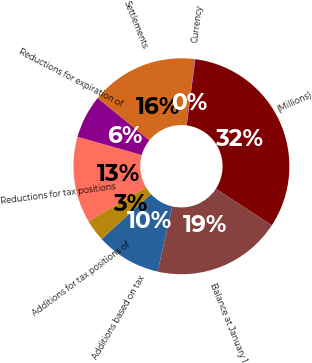Convert chart to OTSL. <chart><loc_0><loc_0><loc_500><loc_500><pie_chart><fcel>(Millions)<fcel>Balance at January 1<fcel>Additions based on tax<fcel>Additions for tax positions of<fcel>Reductions for tax positions<fcel>Reductions for expiration of<fcel>Settlements<fcel>Currency<nl><fcel>32.16%<fcel>19.32%<fcel>9.69%<fcel>3.27%<fcel>12.9%<fcel>6.48%<fcel>16.11%<fcel>0.06%<nl></chart> 